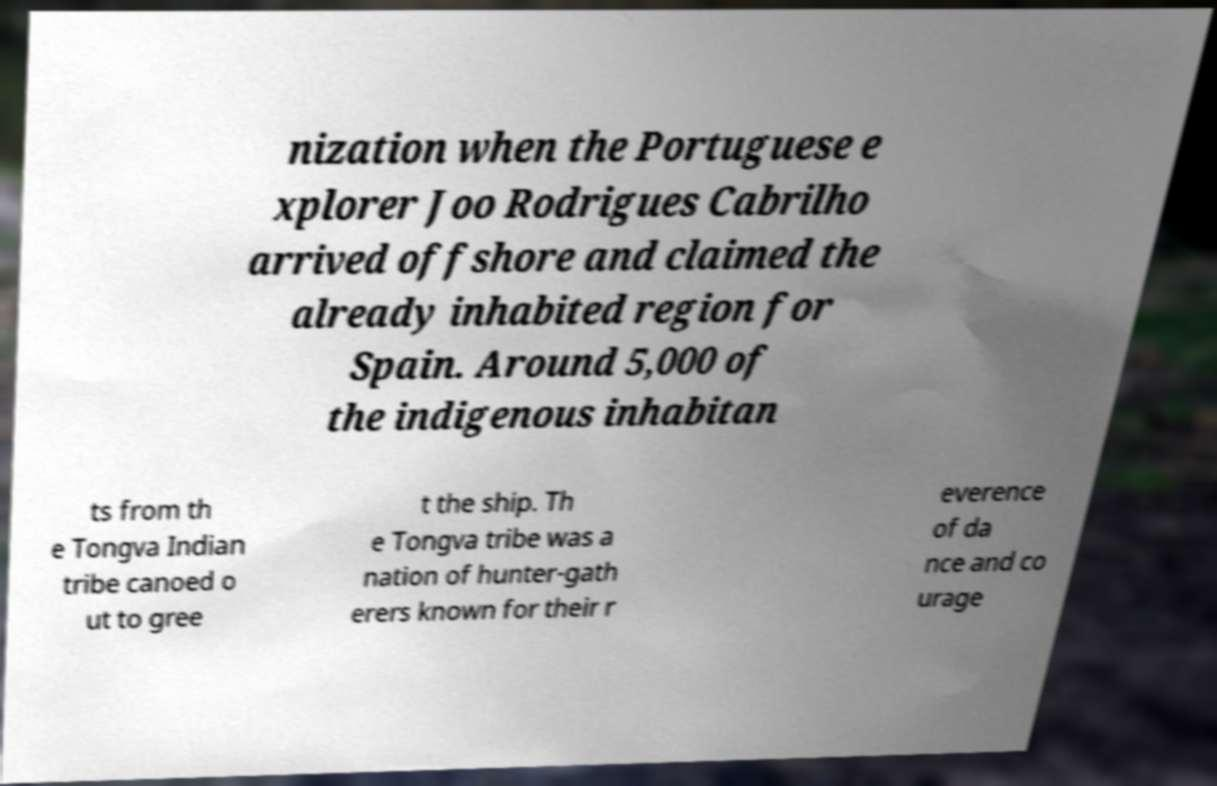Could you assist in decoding the text presented in this image and type it out clearly? nization when the Portuguese e xplorer Joo Rodrigues Cabrilho arrived offshore and claimed the already inhabited region for Spain. Around 5,000 of the indigenous inhabitan ts from th e Tongva Indian tribe canoed o ut to gree t the ship. Th e Tongva tribe was a nation of hunter-gath erers known for their r everence of da nce and co urage 